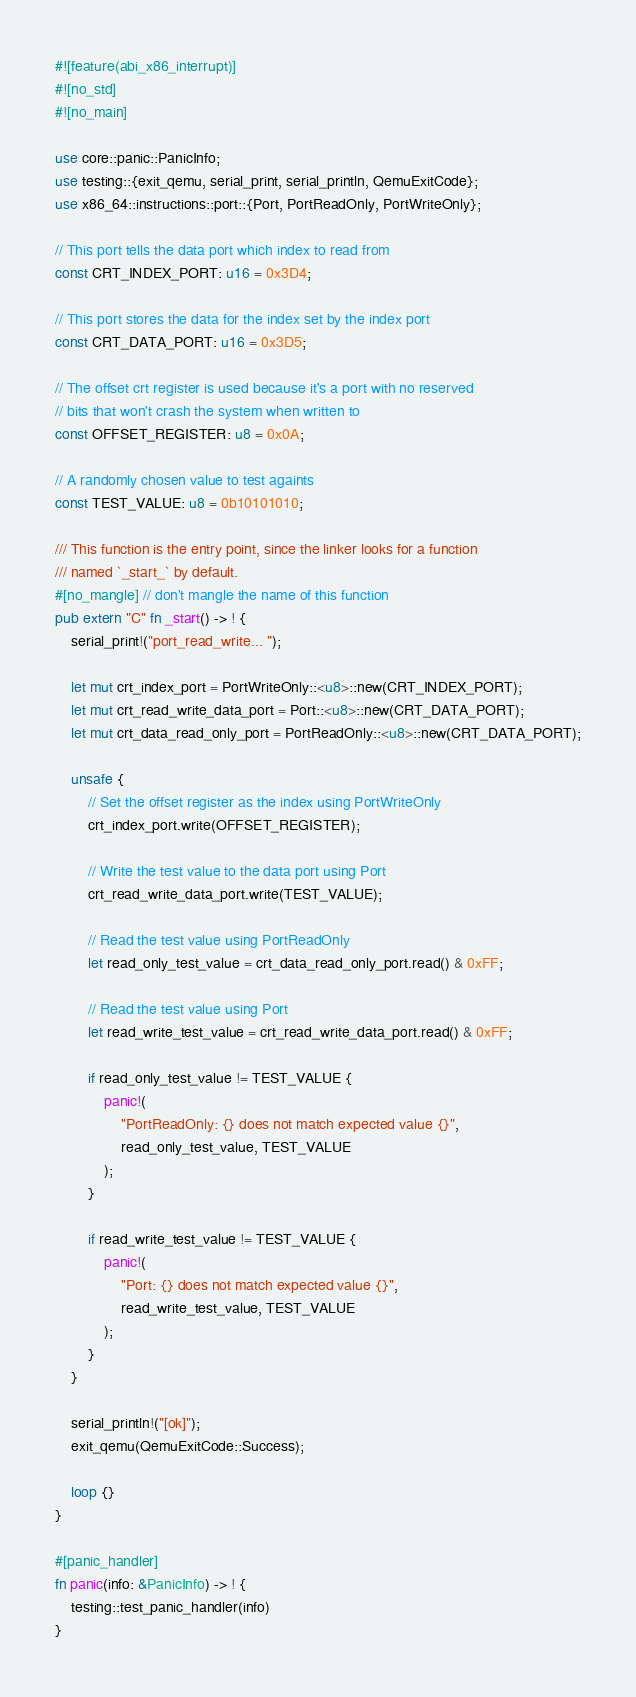<code> <loc_0><loc_0><loc_500><loc_500><_Rust_>#![feature(abi_x86_interrupt)]
#![no_std]
#![no_main]

use core::panic::PanicInfo;
use testing::{exit_qemu, serial_print, serial_println, QemuExitCode};
use x86_64::instructions::port::{Port, PortReadOnly, PortWriteOnly};

// This port tells the data port which index to read from
const CRT_INDEX_PORT: u16 = 0x3D4;

// This port stores the data for the index set by the index port
const CRT_DATA_PORT: u16 = 0x3D5;

// The offset crt register is used because it's a port with no reserved
// bits that won't crash the system when written to
const OFFSET_REGISTER: u8 = 0x0A;

// A randomly chosen value to test againts
const TEST_VALUE: u8 = 0b10101010;

/// This function is the entry point, since the linker looks for a function
/// named `_start_` by default.
#[no_mangle] // don't mangle the name of this function
pub extern "C" fn _start() -> ! {
    serial_print!("port_read_write... ");

    let mut crt_index_port = PortWriteOnly::<u8>::new(CRT_INDEX_PORT);
    let mut crt_read_write_data_port = Port::<u8>::new(CRT_DATA_PORT);
    let mut crt_data_read_only_port = PortReadOnly::<u8>::new(CRT_DATA_PORT);

    unsafe {
        // Set the offset register as the index using PortWriteOnly
        crt_index_port.write(OFFSET_REGISTER);

        // Write the test value to the data port using Port
        crt_read_write_data_port.write(TEST_VALUE);

        // Read the test value using PortReadOnly
        let read_only_test_value = crt_data_read_only_port.read() & 0xFF;

        // Read the test value using Port
        let read_write_test_value = crt_read_write_data_port.read() & 0xFF;

        if read_only_test_value != TEST_VALUE {
            panic!(
                "PortReadOnly: {} does not match expected value {}",
                read_only_test_value, TEST_VALUE
            );
        }

        if read_write_test_value != TEST_VALUE {
            panic!(
                "Port: {} does not match expected value {}",
                read_write_test_value, TEST_VALUE
            );
        }
    }

    serial_println!("[ok]");
    exit_qemu(QemuExitCode::Success);

    loop {}
}

#[panic_handler]
fn panic(info: &PanicInfo) -> ! {
    testing::test_panic_handler(info)
}
</code> 